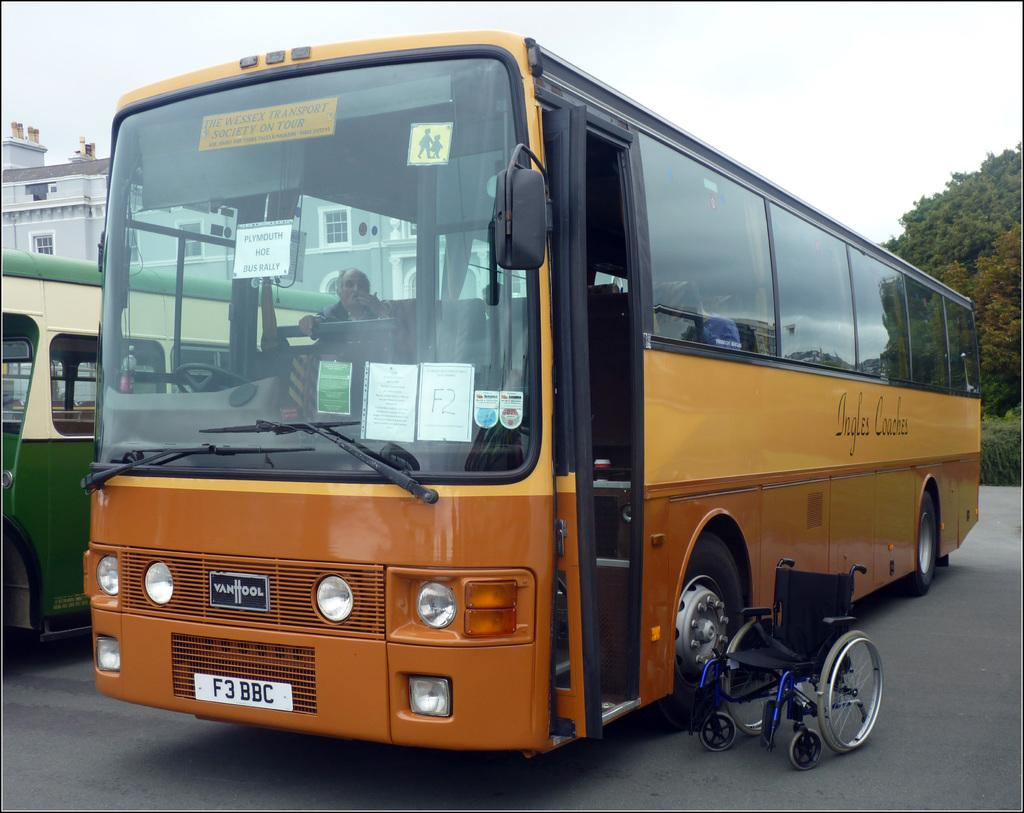<image>
Write a terse but informative summary of the picture. A two tone orange bus with a license plate: "F3 BBC". 